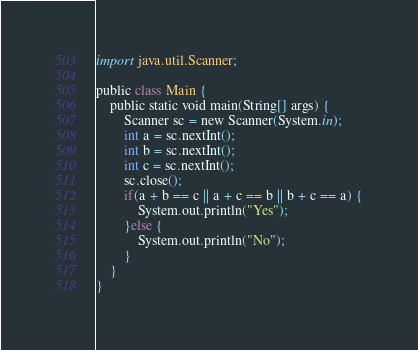Convert code to text. <code><loc_0><loc_0><loc_500><loc_500><_Python_>import java.util.Scanner;

public class Main {
	public static void main(String[] args) {
		Scanner sc = new Scanner(System.in);
		int a = sc.nextInt();
		int b = sc.nextInt();
		int c = sc.nextInt();
		sc.close();
		if(a + b == c || a + c == b || b + c == a) {
			System.out.println("Yes");
		}else {
			System.out.println("No");
		}
	}
}
</code> 